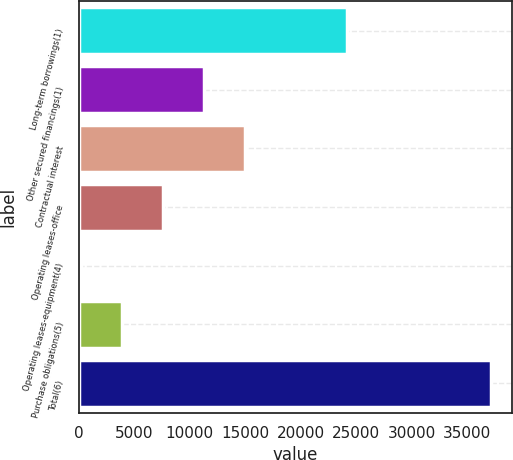<chart> <loc_0><loc_0><loc_500><loc_500><bar_chart><fcel>Long-term borrowings(1)<fcel>Other secured financings(1)<fcel>Contractual interest<fcel>Operating leases-office<fcel>Operating leases-equipment(4)<fcel>Purchase obligations(5)<fcel>Total(6)<nl><fcel>24193<fcel>11305.7<fcel>14994.6<fcel>7616.8<fcel>239<fcel>3927.9<fcel>37128<nl></chart> 